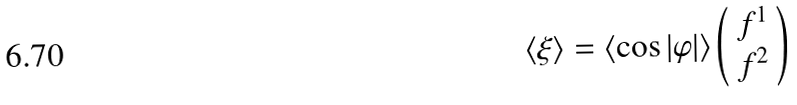<formula> <loc_0><loc_0><loc_500><loc_500>\langle \xi \rangle = \langle \cos | \varphi | \rangle \left ( \begin{array} { c } f ^ { 1 } \\ f ^ { 2 } \end{array} \right )</formula> 